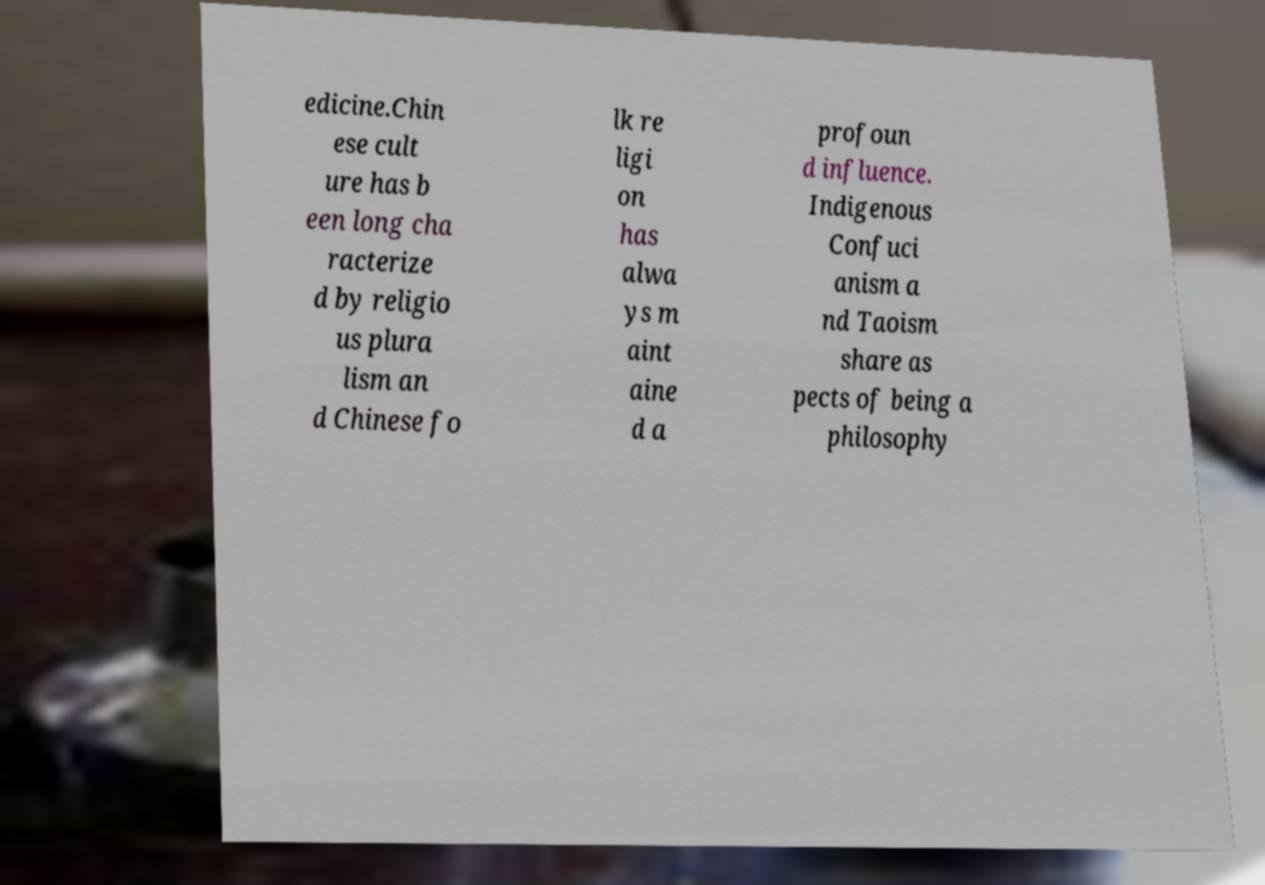Could you extract and type out the text from this image? edicine.Chin ese cult ure has b een long cha racterize d by religio us plura lism an d Chinese fo lk re ligi on has alwa ys m aint aine d a profoun d influence. Indigenous Confuci anism a nd Taoism share as pects of being a philosophy 